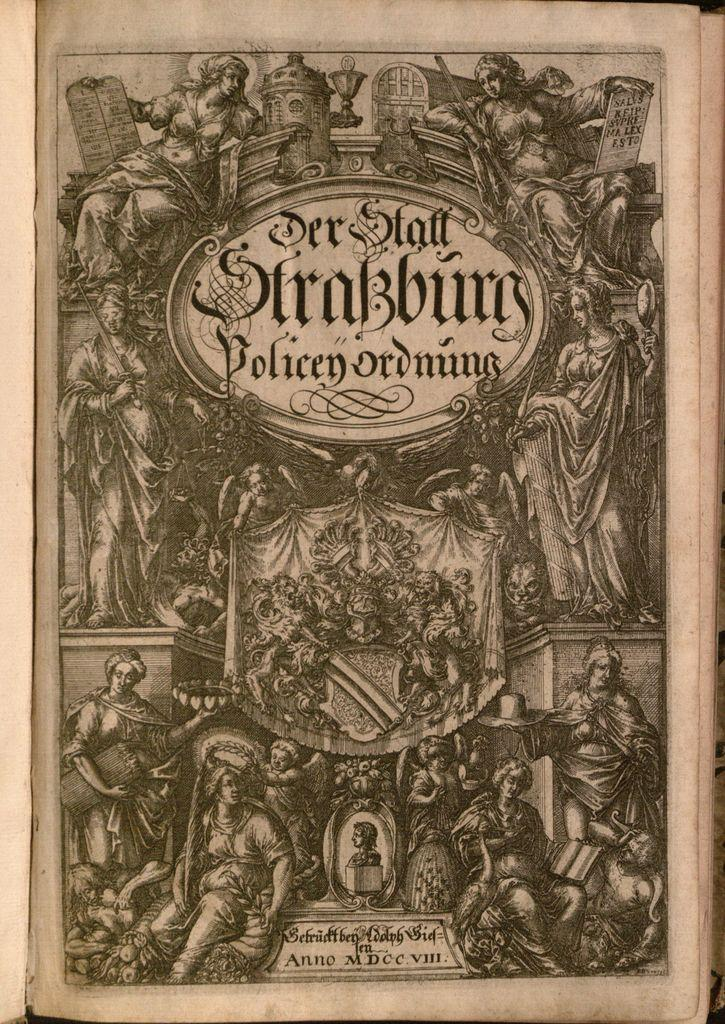<image>
Relay a brief, clear account of the picture shown. An ancient piece or art reading Der Staff Strasburg id presented. 